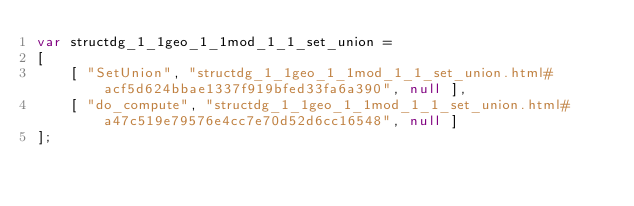<code> <loc_0><loc_0><loc_500><loc_500><_JavaScript_>var structdg_1_1geo_1_1mod_1_1_set_union =
[
    [ "SetUnion", "structdg_1_1geo_1_1mod_1_1_set_union.html#acf5d624bbae1337f919bfed33fa6a390", null ],
    [ "do_compute", "structdg_1_1geo_1_1mod_1_1_set_union.html#a47c519e79576e4cc7e70d52d6cc16548", null ]
];</code> 